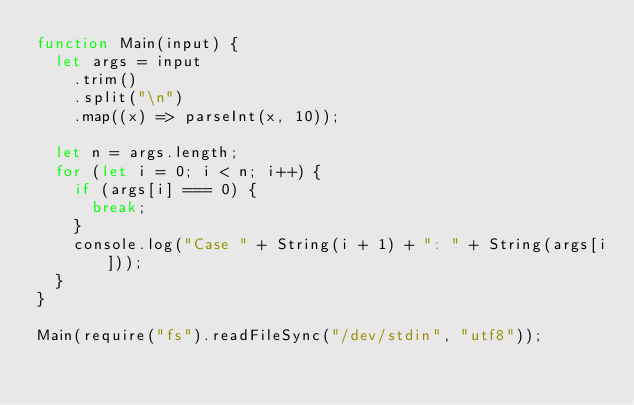<code> <loc_0><loc_0><loc_500><loc_500><_JavaScript_>function Main(input) {
  let args = input
    .trim()
    .split("\n")
    .map((x) => parseInt(x, 10));

  let n = args.length;
  for (let i = 0; i < n; i++) {
    if (args[i] === 0) {
      break;
    }
    console.log("Case " + String(i + 1) + ": " + String(args[i]));
  }
}

Main(require("fs").readFileSync("/dev/stdin", "utf8"));
</code> 